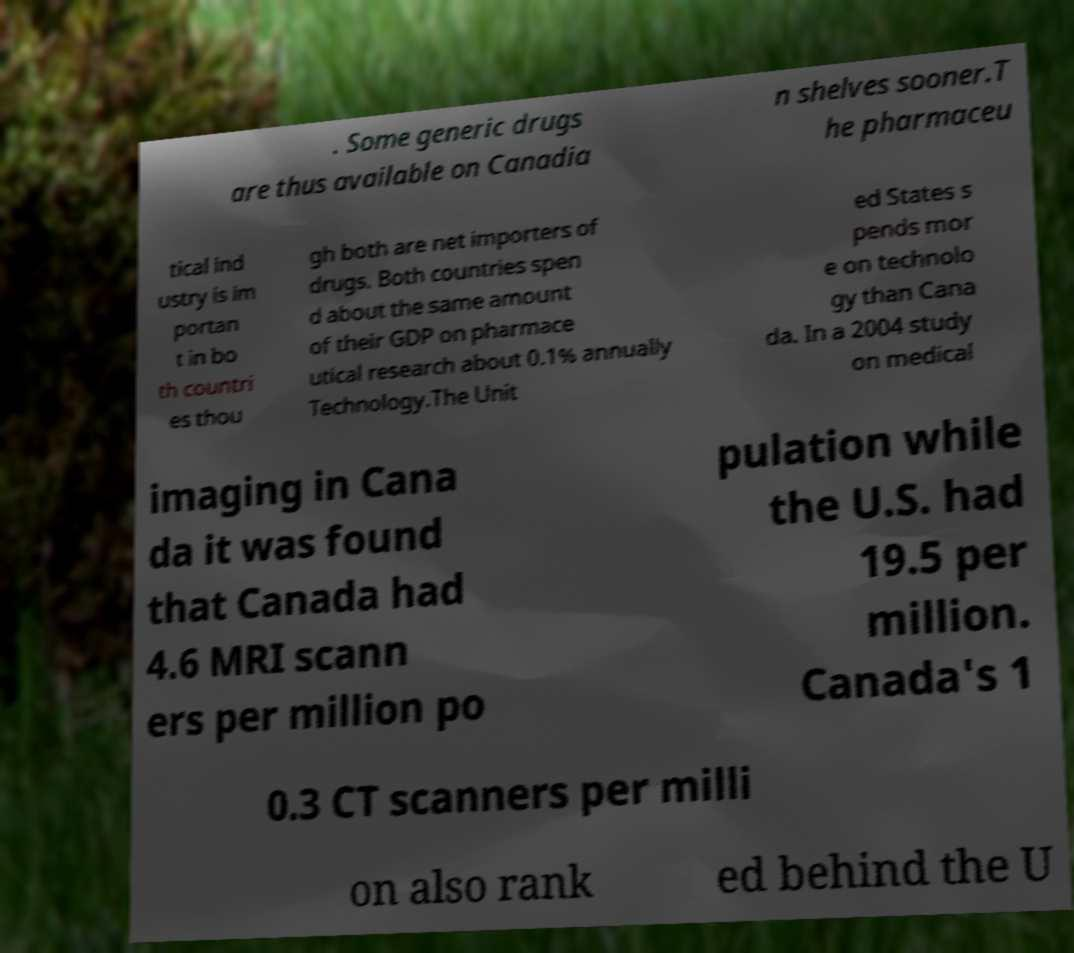Could you extract and type out the text from this image? . Some generic drugs are thus available on Canadia n shelves sooner.T he pharmaceu tical ind ustry is im portan t in bo th countri es thou gh both are net importers of drugs. Both countries spen d about the same amount of their GDP on pharmace utical research about 0.1% annually Technology.The Unit ed States s pends mor e on technolo gy than Cana da. In a 2004 study on medical imaging in Cana da it was found that Canada had 4.6 MRI scann ers per million po pulation while the U.S. had 19.5 per million. Canada's 1 0.3 CT scanners per milli on also rank ed behind the U 